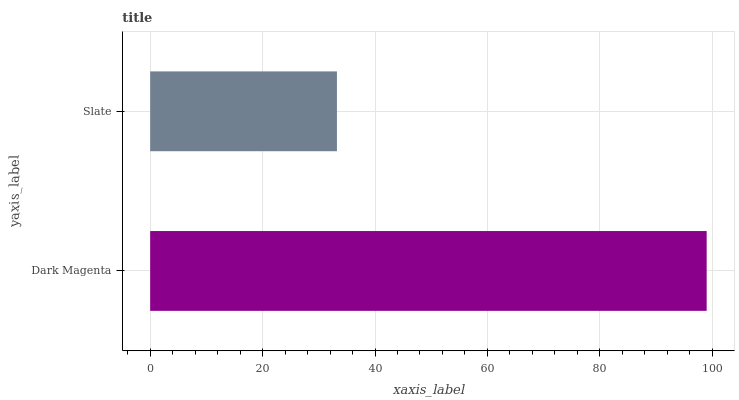Is Slate the minimum?
Answer yes or no. Yes. Is Dark Magenta the maximum?
Answer yes or no. Yes. Is Slate the maximum?
Answer yes or no. No. Is Dark Magenta greater than Slate?
Answer yes or no. Yes. Is Slate less than Dark Magenta?
Answer yes or no. Yes. Is Slate greater than Dark Magenta?
Answer yes or no. No. Is Dark Magenta less than Slate?
Answer yes or no. No. Is Dark Magenta the high median?
Answer yes or no. Yes. Is Slate the low median?
Answer yes or no. Yes. Is Slate the high median?
Answer yes or no. No. Is Dark Magenta the low median?
Answer yes or no. No. 